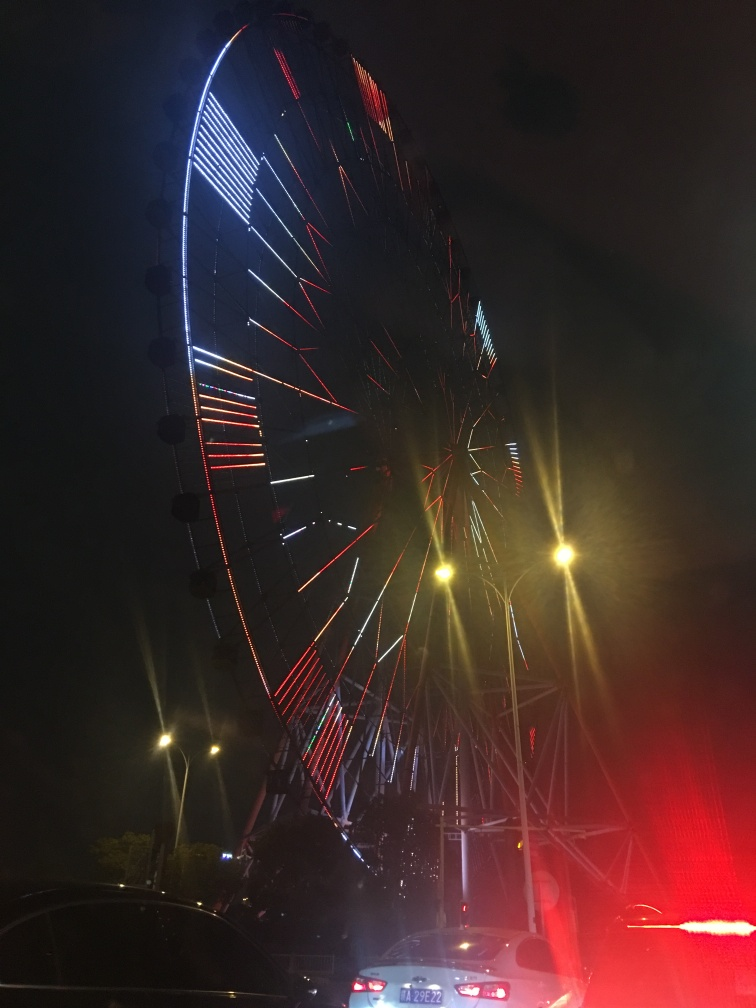Are there any notable features or landmarks? The most notable feature in the image is the large ferris wheel adorned with colorful lights, creating a striking visual feature against the night sky. There are no immediately recognizable landmarks that indicate the specific location of the ferris wheel. 